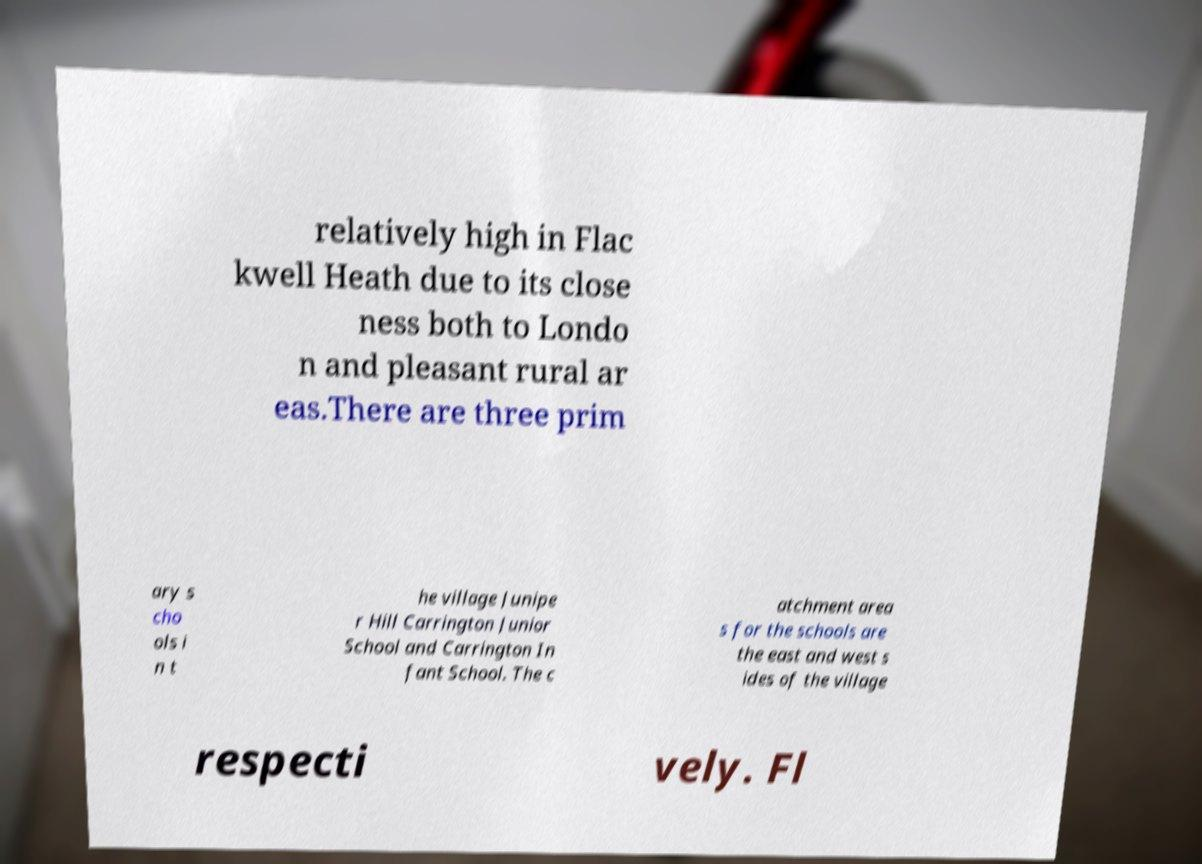Please identify and transcribe the text found in this image. relatively high in Flac kwell Heath due to its close ness both to Londo n and pleasant rural ar eas.There are three prim ary s cho ols i n t he village Junipe r Hill Carrington Junior School and Carrington In fant School. The c atchment area s for the schools are the east and west s ides of the village respecti vely. Fl 